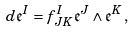<formula> <loc_0><loc_0><loc_500><loc_500>d \mathfrak { e } ^ { I } = f ^ { I } _ { J K } \mathfrak { e } ^ { J } \wedge \mathfrak { e } ^ { K } \, ,</formula> 